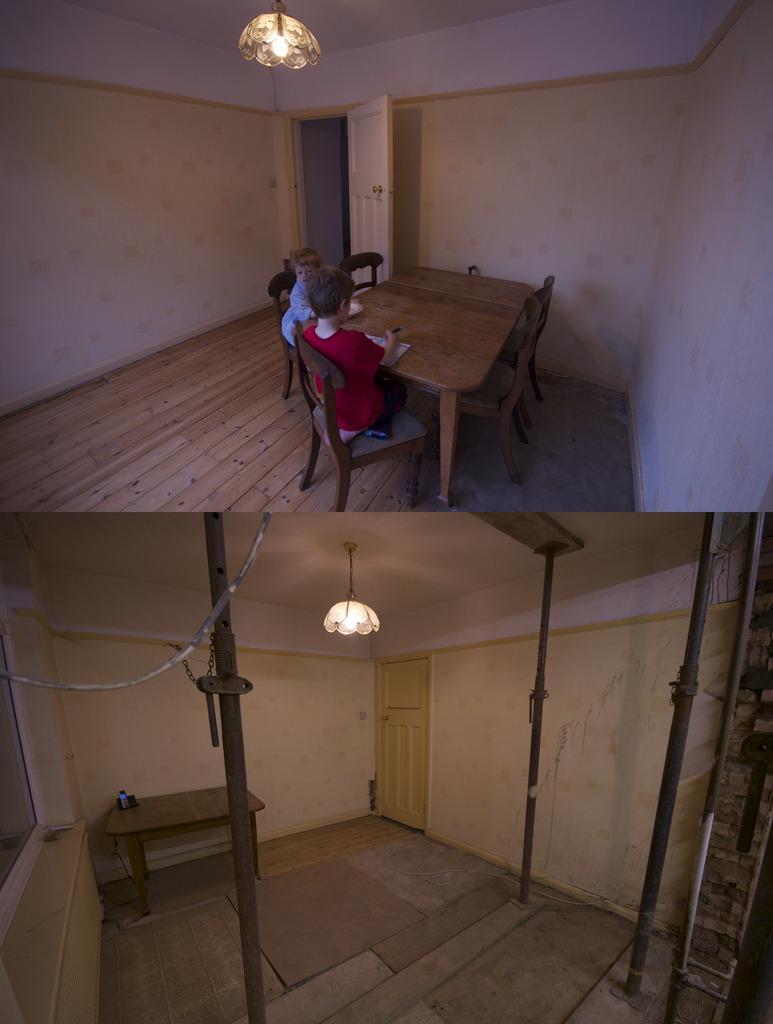How would you summarize this image in a sentence or two? In this image I can see two people sitting on the chairs and they are in-front of the table. Among them one person is wearing the red t-shirt and they are holding something. To the top there is a light. In the down image there is a door,table,light and the two poles can be seen. 